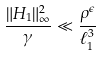Convert formula to latex. <formula><loc_0><loc_0><loc_500><loc_500>\frac { \| H _ { 1 } \| _ { \infty } ^ { 2 } } { \gamma } \ll \frac { \rho ^ { \epsilon } } { \ell _ { 1 } ^ { 3 } }</formula> 